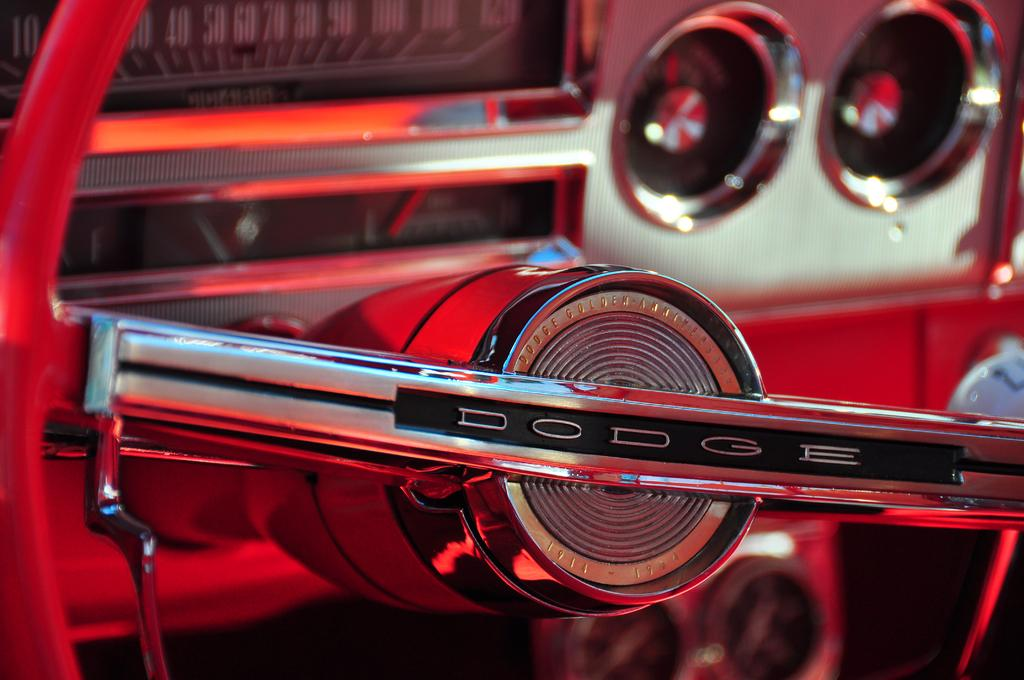What type of setting is depicted in the image? The image shows the interior of a motor vehicle. How many waves can be seen crashing against the shore in the image? There are no waves present in the image, as it depicts the interior of a motor vehicle. 